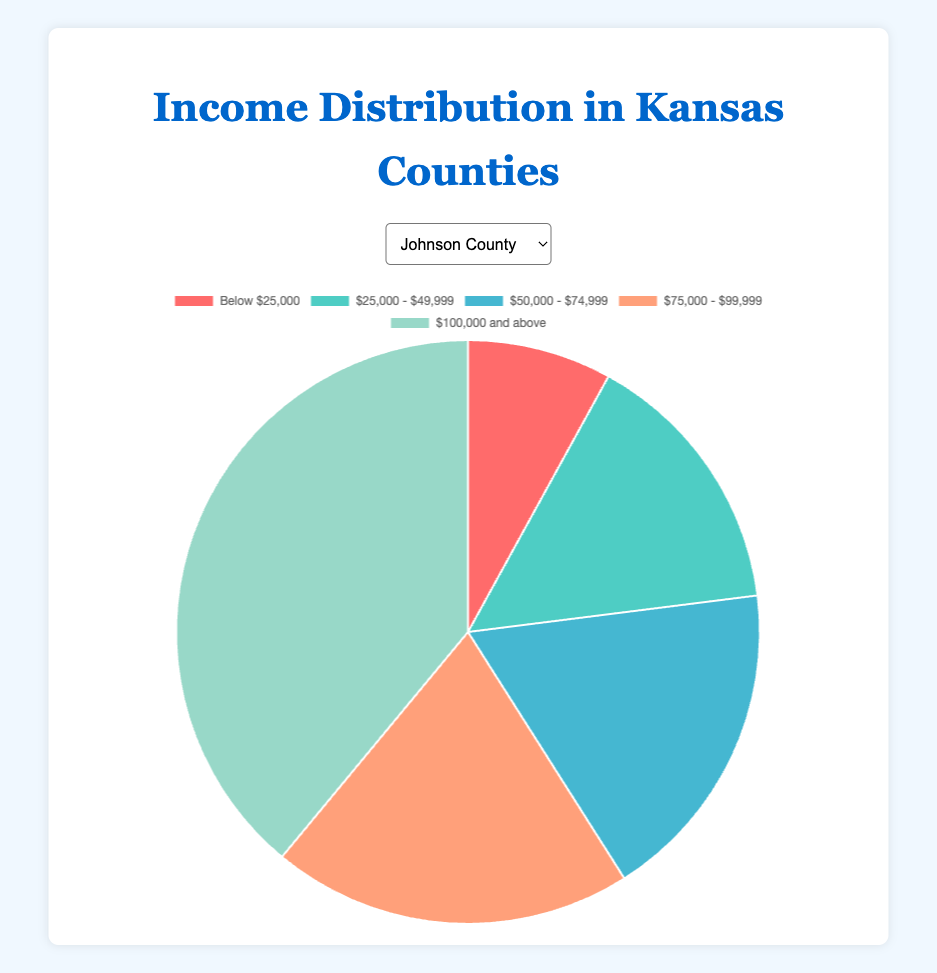Which county has the highest percentage of households earning "Below $25,000"? To determine this, look at the pie chart segments for each county and compare the percentages for the "Below $25,000" income bracket. Johnson County is 8%, Sedgwick County is 12%, Shawnee County is 10%, and Douglas County is 14%.
Answer: Douglas County What is the combined percentage of households in Johnson County earning "$75,000 and above"? Add the percentages for the income brackets "$75,000 - $99,999" and "$100,000 and above" in Johnson County. This is 20% + 39% = 59%.
Answer: 59% How does the percentage of households earning "$50,000 - $74,999" in Shawnee County compare to Sedgwick County? Look at the pie chart segments for the "$50,000 - $74,999" income bracket in Shawnee County and Sedgwick County. Shawnee County is 22%, and Sedgwick County is 25%. Since 22% is less than 25%, Shawnee County's percentage is lower.
Answer: Less Which county has the smallest segment for the income bracket "$100,000 and above"? Examine the pie chart segments for the "$100,000 and above" bracket for each county. Johnson County is 39%, Sedgwick County is 25%, Shawnee County is 26%, and Douglas County is 25%. The smallest segment is Johnson County.
Answer: Johnson County What is the total percentage of households in Shawnee County earning below $75,000? Sum the percentages of the income brackets "Below $25,000", "$25,000 - $49,999", and "$50,000 - $74,999" in Shawnee County. This is 10% + 18% + 22% = 50%.
Answer: 50% Which county has the highest percentage of households in the highest income bracket? Compare the percentages of the "$100,000 and above" bracket in each county. Johnson County is 39%, Sedgwick County is 25%, Shawnee County is 26%, and Douglas County is 25%. Johnson County has the highest percentage.
Answer: Johnson County What is the difference in percentage of households earning "$75,000 - $99,999" between Johnson County and Douglas County? Subtract the percentage for the "$75,000 - $99,999" bracket in Douglas County from that in Johnson County. This is 20% - 22% = -2%.
Answer: -2% In which county does the income bracket "Below $25,000" occupy the largest segment visually? Visually inspect the pie chart segments for the "Below $25,000" category in each county. Johnson County is 8%, Sedgwick County is 12%, Shawnee County is 10%, and Douglas County is 14%. The largest segment is in Douglas County.
Answer: Douglas County What is the average percentage of households earning "$100,000 and above" across all counties? Add the percentages of the "$100,000 and above" bracket for all counties and then divide by the number of counties. This is (39% + 25% + 26% + 25%) / 4 = 28.75%.
Answer: 28.75% 